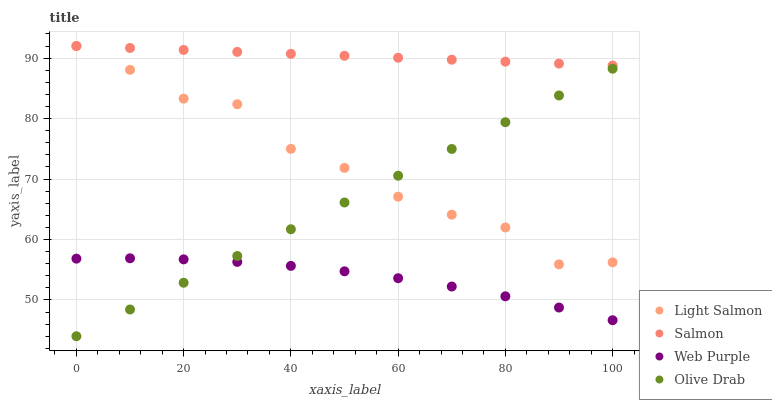Does Web Purple have the minimum area under the curve?
Answer yes or no. Yes. Does Salmon have the maximum area under the curve?
Answer yes or no. Yes. Does Salmon have the minimum area under the curve?
Answer yes or no. No. Does Web Purple have the maximum area under the curve?
Answer yes or no. No. Is Olive Drab the smoothest?
Answer yes or no. Yes. Is Light Salmon the roughest?
Answer yes or no. Yes. Is Salmon the smoothest?
Answer yes or no. No. Is Salmon the roughest?
Answer yes or no. No. Does Olive Drab have the lowest value?
Answer yes or no. Yes. Does Web Purple have the lowest value?
Answer yes or no. No. Does Salmon have the highest value?
Answer yes or no. Yes. Does Web Purple have the highest value?
Answer yes or no. No. Is Olive Drab less than Salmon?
Answer yes or no. Yes. Is Light Salmon greater than Web Purple?
Answer yes or no. Yes. Does Olive Drab intersect Web Purple?
Answer yes or no. Yes. Is Olive Drab less than Web Purple?
Answer yes or no. No. Is Olive Drab greater than Web Purple?
Answer yes or no. No. Does Olive Drab intersect Salmon?
Answer yes or no. No. 